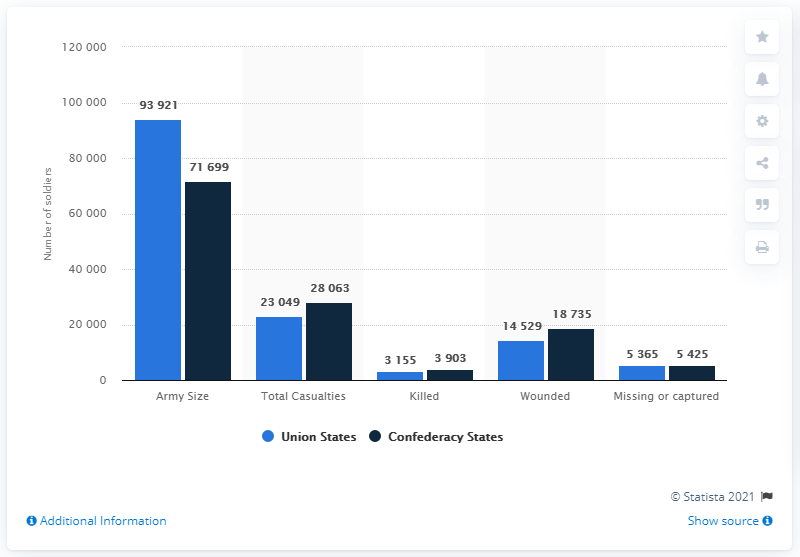Mention a couple of crucial points in this snapshot. A total of 40,322 soldiers were killed and wounded. What is the size of the Union army? The number is approximately 93,921. 